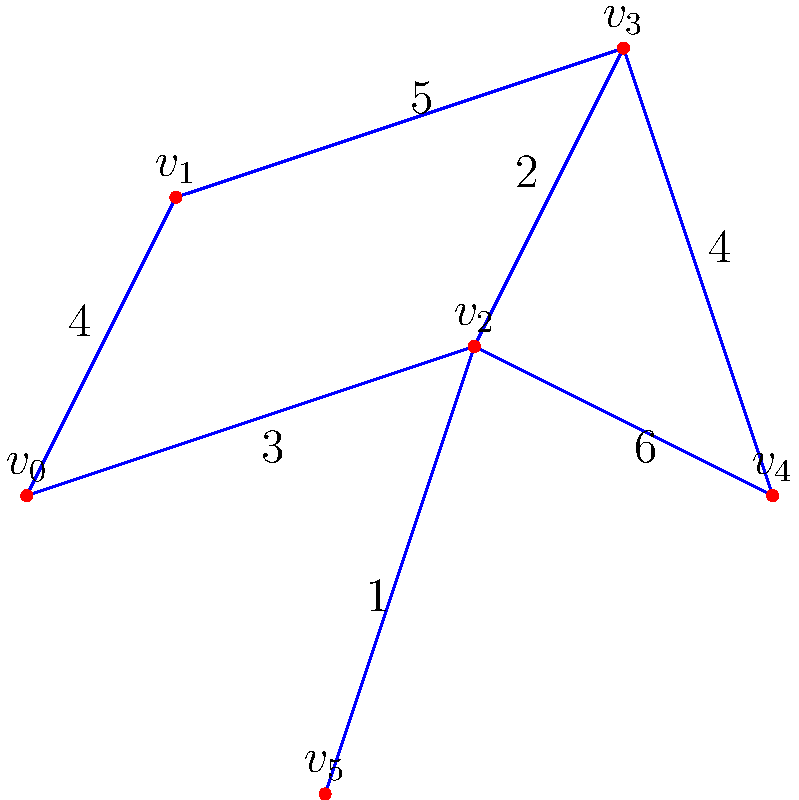As a software engineer working on a project to optimize hiking trails in a national park, you're tasked with finding the minimum spanning tree of the trail network. The graph represents trail intersections (vertices) and connecting paths (edges), with edge weights indicating trail distances in kilometers. What is the total distance of the optimized trail network (i.e., the sum of edge weights in the minimum spanning tree)? To find the minimum spanning tree (MST) and calculate its total weight, we'll use Kruskal's algorithm:

1. Sort edges by weight in ascending order:
   $(v_2, v_5): 1$
   $(v_2, v_3): 2$
   $(v_0, v_2): 3$
   $(v_0, v_1): 4$
   $(v_3, v_4): 4$
   $(v_1, v_3): 5$
   $(v_2, v_4): 6$

2. Add edges to the MST, skipping those that create cycles:
   - Add $(v_2, v_5): 1$
   - Add $(v_2, v_3): 2$
   - Add $(v_0, v_2): 3$
   - Add $(v_0, v_1): 4$
   - Add $(v_3, v_4): 4$

3. The MST is complete with 5 edges (for 6 vertices).

4. Sum the weights of the selected edges:
   $1 + 2 + 3 + 4 + 4 = 14$

Therefore, the total distance of the optimized trail network is 14 kilometers.
Answer: 14 kilometers 